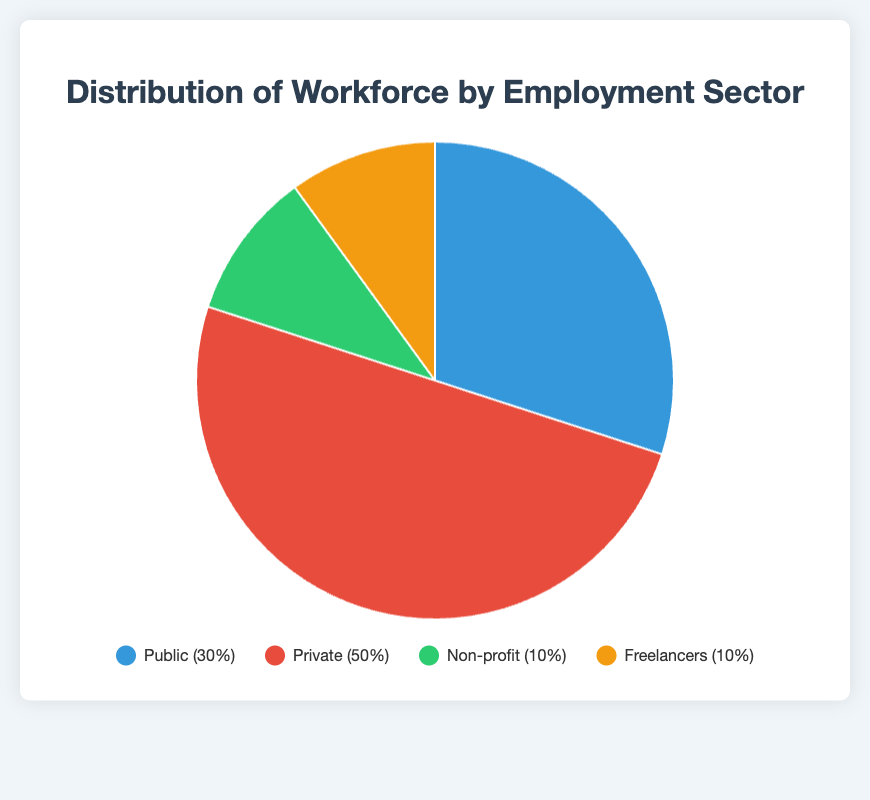Which employment sector has the highest percentage of the workforce? The figure shows the breakdown of employment sectors and their respective percentages. The Private sector has the highest percentage, which is 50%.
Answer: Private What is the total percentage of the workforce employed in the Public sector? Summing the percentages of the Federal, State, and Local Government breakdowns within the Public sector (10% + 12% + 8%) yields 30%.
Answer: 30% How does the combined percentage of Non-profit and Freelancers compare to the Public sector? The Non-profit sector is 10% and Freelancers are 10%. Together, they have a total of 10% + 10% = 20%, which is less than the Public sector’s 30%.
Answer: Less than Which specific sector within the Public employment sector has the smallest percentage of the workforce? The breakdown of the Public sector specifies Federal Government at 10%, State Government at 12%, and Local Government at 8%. Hence, Local Government has the smallest percentage.
Answer: Local Government What is the difference in percentage between Corporate Enterprises and Charitable Organizations? The breakdown shows Corporate Enterprises at 35% and Charitable Organizations at 6%. The difference is 35% - 6% = 29%.
Answer: 29% If you combine the percentages of Technology Services and Consulting Services within the Freelancers sector, is it more than the percentage of Educational Institutions within Non-profit? Technology Services are 4% and Consulting Services are 3%, combined it is 4% + 3% = 7%. Educational Institutions are 4%. Thus, combined Freelancers sectors have a higher percentage (7%) than Educational Institutions.
Answer: More than What color represents the Private sector in the pie chart? The pie chart legend and the figure indicate that the Private sector is represented by the red color.
Answer: Red Which sector has the least representation and what is its entity with the smallest percentage? Non-profit and Freelancers both have 10%, but typically Non-profit is considered smaller due to less diversity. Charitable Organizations within Non-profit have 6% which is the smallest entity.
Answer: Non-profit, Charitable Organizations How much more percentage does the Private sector contribute compared to the combined Public and Freelancers sectors? The Private sector is 50%, Public sector is 30%, and Freelancers are 10%. Combined Public and Freelancers make up 30% + 10% = 40%. The difference is 50% - 40% = 10%.
Answer: 10% 